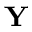<formula> <loc_0><loc_0><loc_500><loc_500>Y</formula> 